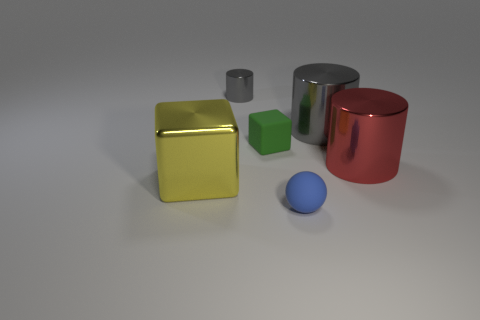How many gray things are metallic things or large objects?
Your answer should be compact. 2. There is a tiny cylinder that is the same material as the big yellow thing; what color is it?
Give a very brief answer. Gray. Is the thing in front of the yellow object made of the same material as the cube that is on the right side of the large yellow block?
Your response must be concise. Yes. There is a thing that is the same color as the tiny cylinder; what is its size?
Your answer should be very brief. Large. There is a gray thing right of the small blue sphere; what is it made of?
Your response must be concise. Metal. Do the rubber object behind the small blue sphere and the tiny matte object in front of the red metal thing have the same shape?
Keep it short and to the point. No. There is a object that is the same color as the small metallic cylinder; what is its material?
Keep it short and to the point. Metal. Is there a small blue object?
Your response must be concise. Yes. What is the material of the tiny gray thing that is the same shape as the large red metallic object?
Provide a short and direct response. Metal. Are there any shiny cylinders in front of the tiny gray cylinder?
Give a very brief answer. Yes. 